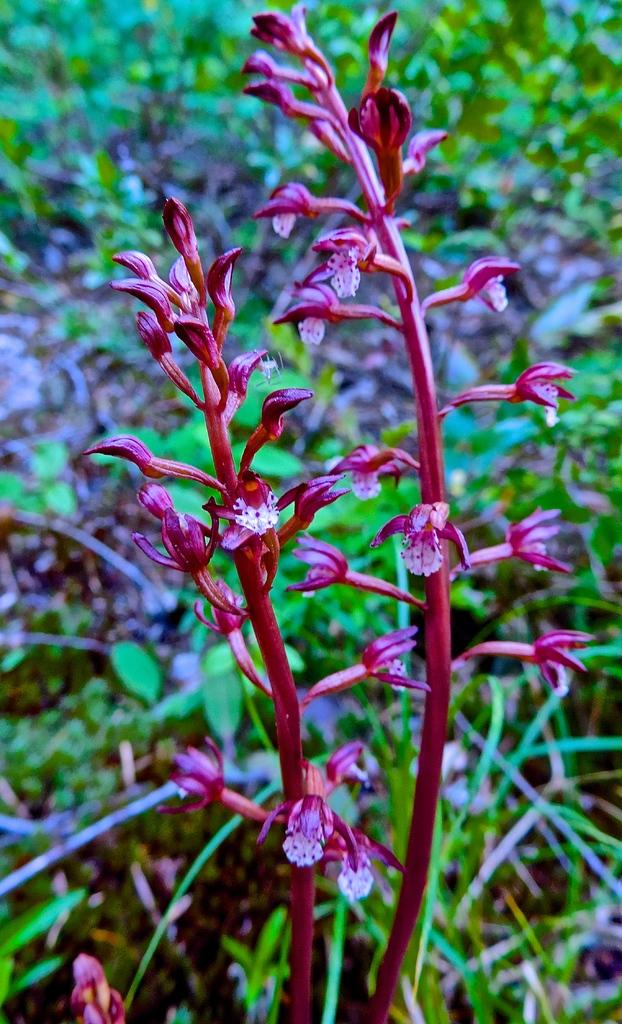What type of living organisms can be seen in the image? There are flowers and plants in the image. Can you describe the background of the image? The background of the image is blurred. What type of match is being played in the image? There is no match being played in the image; it features flowers and plants. Can you tell me how many aunts are present in the image? There are no people, including aunts, present in the image; it features flowers and plants. 